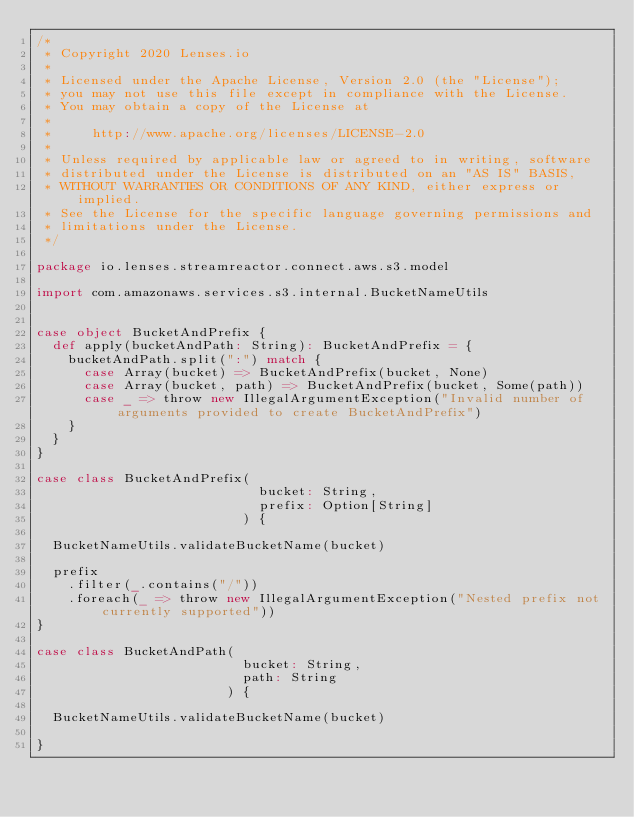<code> <loc_0><loc_0><loc_500><loc_500><_Scala_>/*
 * Copyright 2020 Lenses.io
 *
 * Licensed under the Apache License, Version 2.0 (the "License");
 * you may not use this file except in compliance with the License.
 * You may obtain a copy of the License at
 *
 *     http://www.apache.org/licenses/LICENSE-2.0
 *
 * Unless required by applicable law or agreed to in writing, software
 * distributed under the License is distributed on an "AS IS" BASIS,
 * WITHOUT WARRANTIES OR CONDITIONS OF ANY KIND, either express or implied.
 * See the License for the specific language governing permissions and
 * limitations under the License.
 */

package io.lenses.streamreactor.connect.aws.s3.model

import com.amazonaws.services.s3.internal.BucketNameUtils


case object BucketAndPrefix {
  def apply(bucketAndPath: String): BucketAndPrefix = {
    bucketAndPath.split(":") match {
      case Array(bucket) => BucketAndPrefix(bucket, None)
      case Array(bucket, path) => BucketAndPrefix(bucket, Some(path))
      case _ => throw new IllegalArgumentException("Invalid number of arguments provided to create BucketAndPrefix")
    }
  }
}

case class BucketAndPrefix(
                            bucket: String,
                            prefix: Option[String]
                          ) {

  BucketNameUtils.validateBucketName(bucket)

  prefix
    .filter(_.contains("/"))
    .foreach(_ => throw new IllegalArgumentException("Nested prefix not currently supported"))
}

case class BucketAndPath(
                          bucket: String,
                          path: String
                        ) {

  BucketNameUtils.validateBucketName(bucket)

}
</code> 